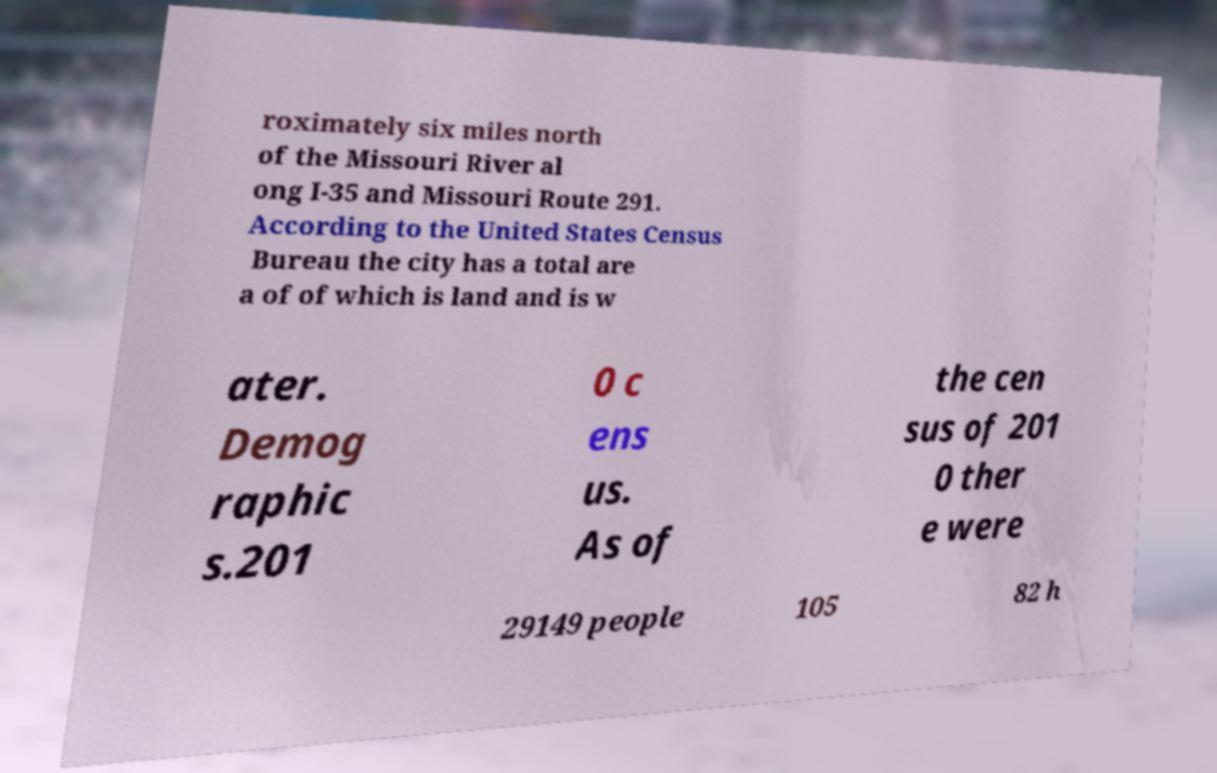Please identify and transcribe the text found in this image. roximately six miles north of the Missouri River al ong I-35 and Missouri Route 291. According to the United States Census Bureau the city has a total are a of of which is land and is w ater. Demog raphic s.201 0 c ens us. As of the cen sus of 201 0 ther e were 29149 people 105 82 h 